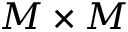Convert formula to latex. <formula><loc_0><loc_0><loc_500><loc_500>M \times M</formula> 